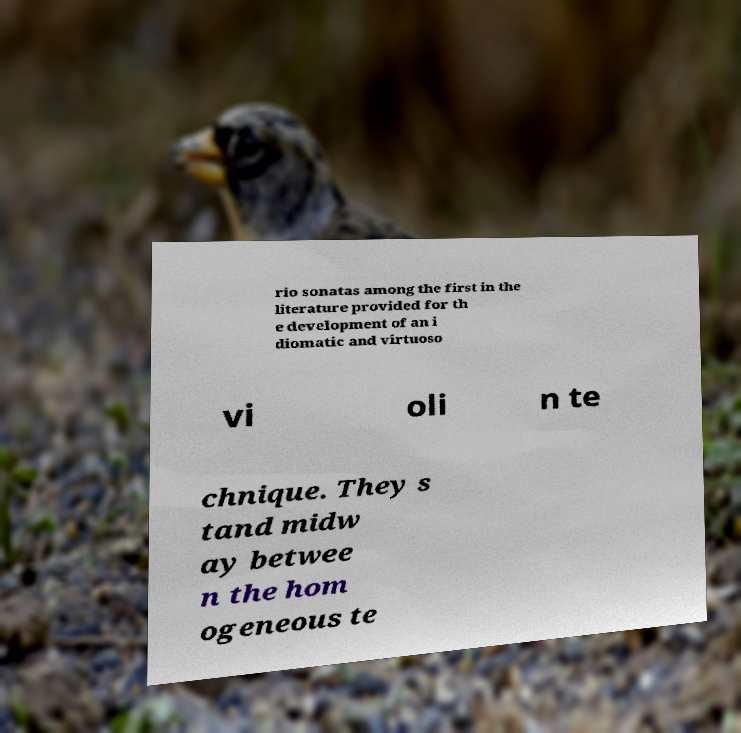Please identify and transcribe the text found in this image. rio sonatas among the first in the literature provided for th e development of an i diomatic and virtuoso vi oli n te chnique. They s tand midw ay betwee n the hom ogeneous te 